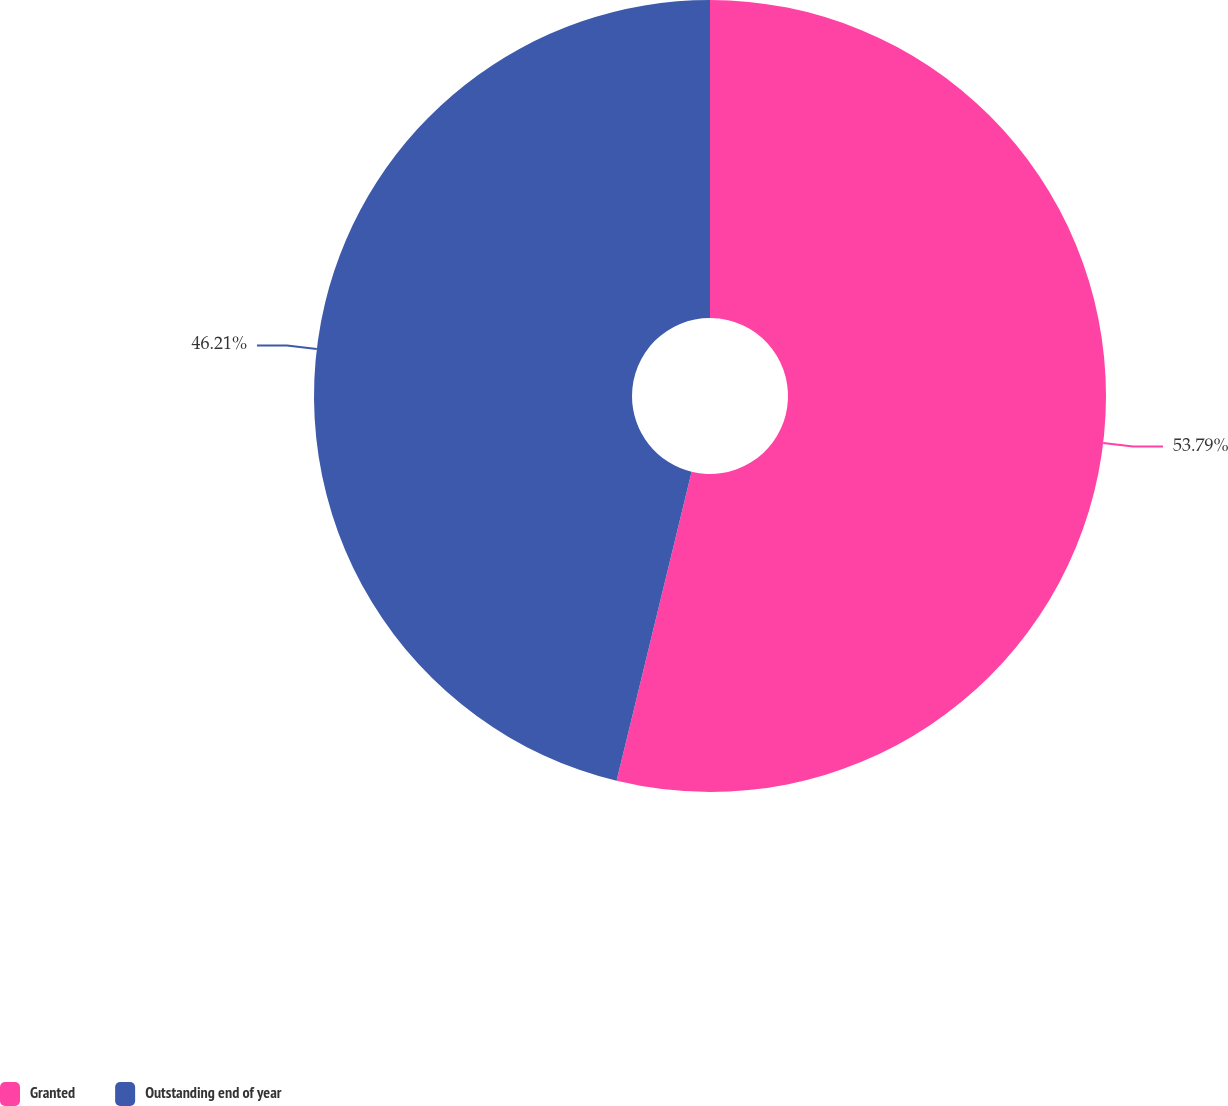Convert chart. <chart><loc_0><loc_0><loc_500><loc_500><pie_chart><fcel>Granted<fcel>Outstanding end of year<nl><fcel>53.79%<fcel>46.21%<nl></chart> 